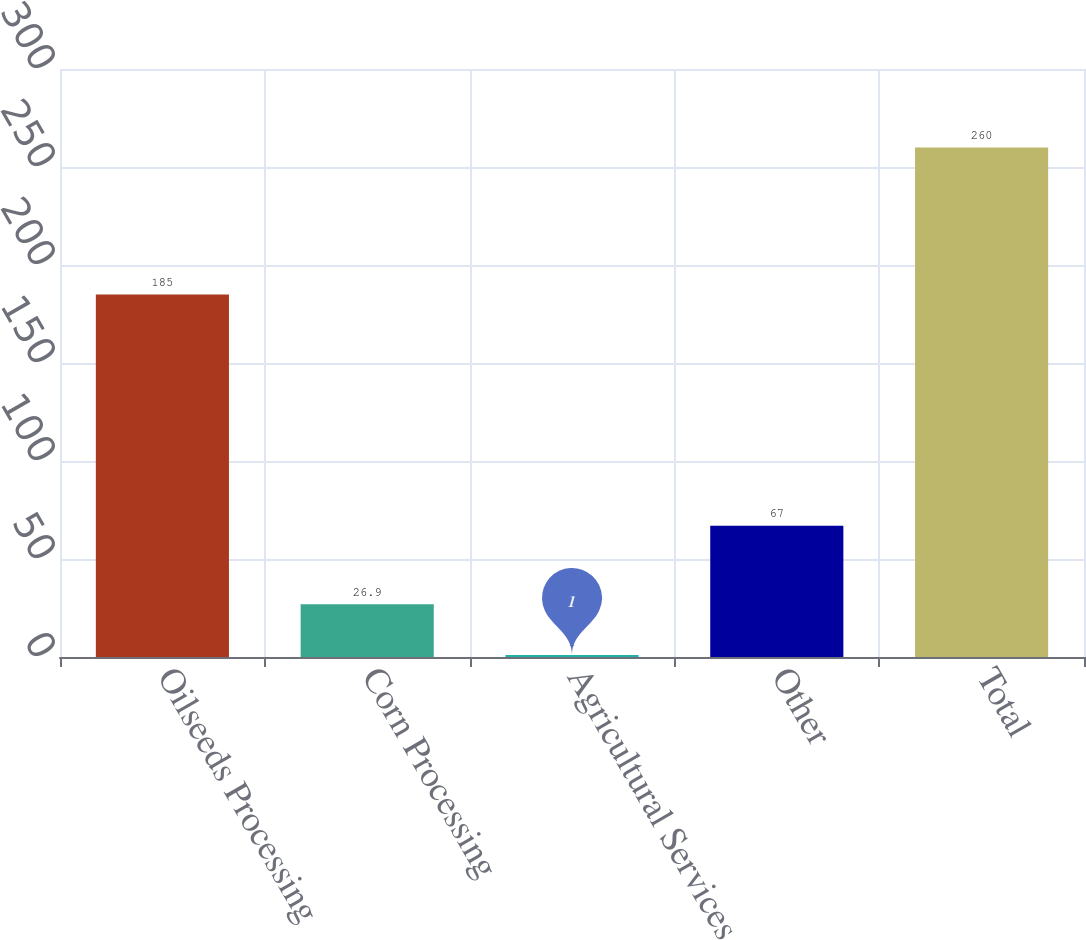Convert chart. <chart><loc_0><loc_0><loc_500><loc_500><bar_chart><fcel>Oilseeds Processing<fcel>Corn Processing<fcel>Agricultural Services<fcel>Other<fcel>Total<nl><fcel>185<fcel>26.9<fcel>1<fcel>67<fcel>260<nl></chart> 